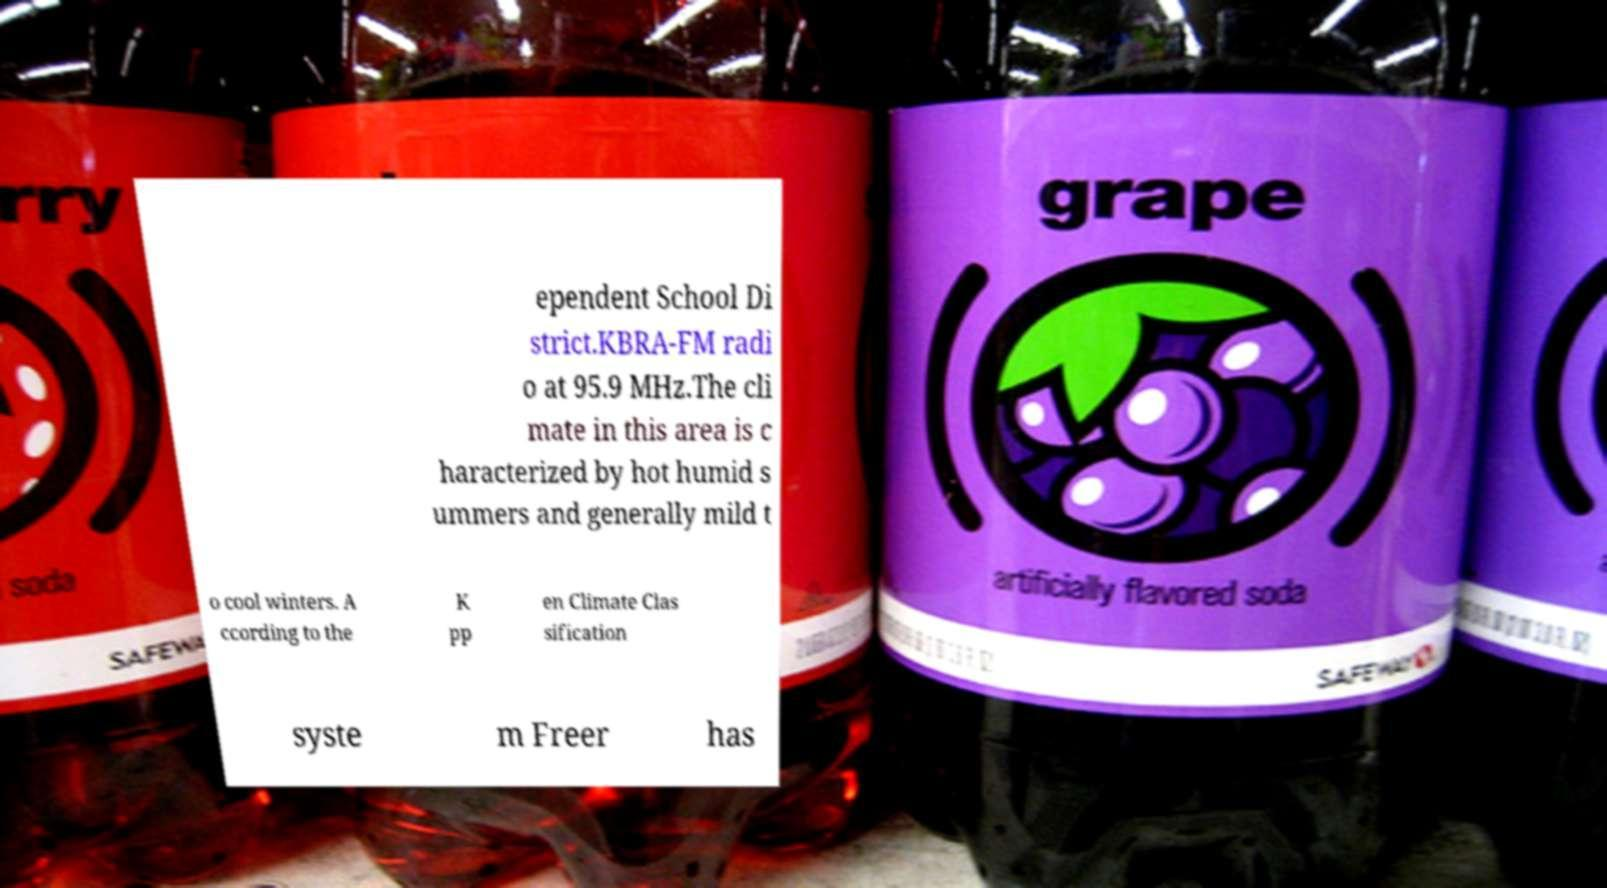There's text embedded in this image that I need extracted. Can you transcribe it verbatim? ependent School Di strict.KBRA-FM radi o at 95.9 MHz.The cli mate in this area is c haracterized by hot humid s ummers and generally mild t o cool winters. A ccording to the K pp en Climate Clas sification syste m Freer has 